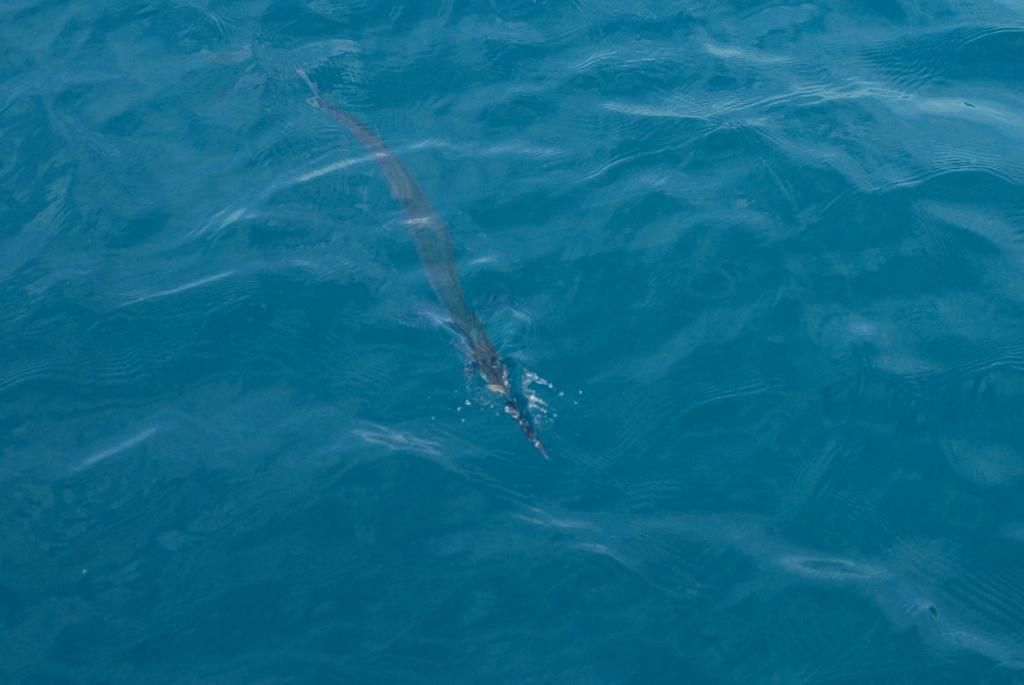What is the primary element present in the image? There is water in the image. What type of creature can be seen in the water? There is a water animal in the image. What type of coach can be seen in the image? There is no coach present in the image; it features water and a water animal. What type of locket is being used to feed the water animal in the image? There is no locket present in the image, and water animals do not require feeding in this manner. 